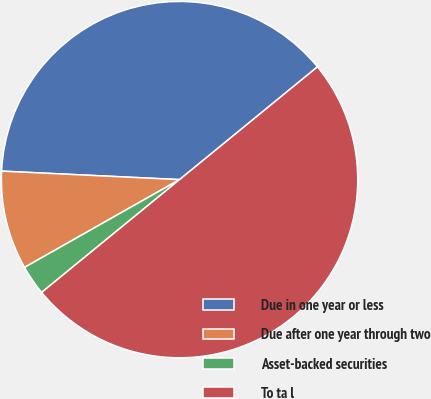Convert chart. <chart><loc_0><loc_0><loc_500><loc_500><pie_chart><fcel>Due in one year or less<fcel>Due after one year through two<fcel>Asset-backed securities<fcel>To ta l<nl><fcel>38.33%<fcel>8.96%<fcel>2.71%<fcel>50.0%<nl></chart> 